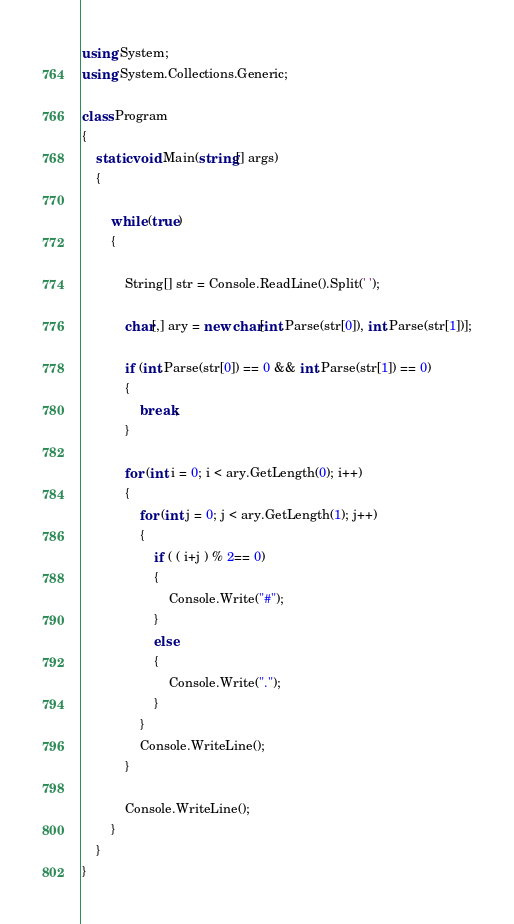Convert code to text. <code><loc_0><loc_0><loc_500><loc_500><_C#_>using System;
using System.Collections.Generic;

class Program
{
    static void Main(string[] args)
    {

        while (true)
        {

            String[] str = Console.ReadLine().Split(' ');

            char[,] ary = new char[int.Parse(str[0]), int.Parse(str[1])];

            if (int.Parse(str[0]) == 0 && int.Parse(str[1]) == 0)
            {
                break;
            }

            for (int i = 0; i < ary.GetLength(0); i++)
            {
                for (int j = 0; j < ary.GetLength(1); j++)
                {
                    if ( ( i+j ) % 2== 0)
                    {
                        Console.Write("#");
                    }
                    else
                    {
                        Console.Write(".");
                    }
                }
                Console.WriteLine();
            }

            Console.WriteLine();
        }
    }
}</code> 